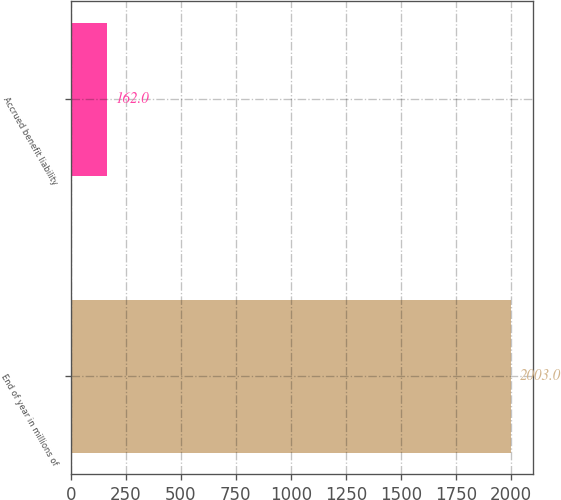<chart> <loc_0><loc_0><loc_500><loc_500><bar_chart><fcel>End of year in millions of<fcel>Accrued benefit liability<nl><fcel>2003<fcel>162<nl></chart> 